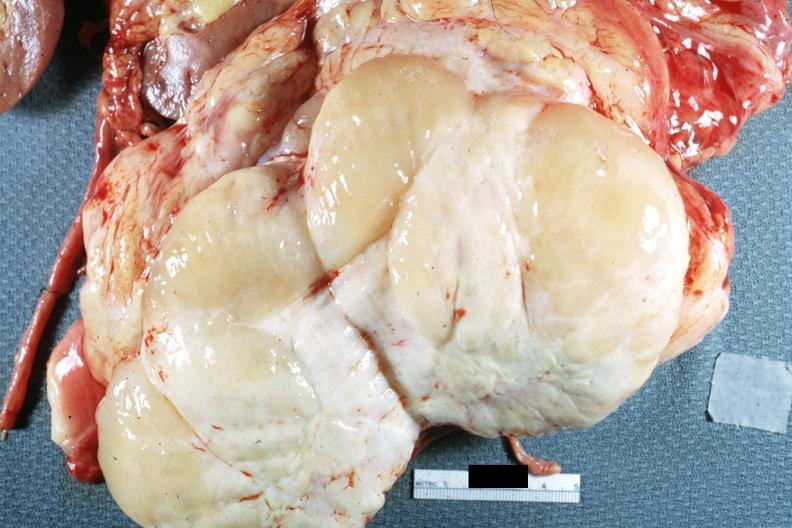does this image show nodular tumor cut surface natural color yellow and white typical gross sarcoma?
Answer the question using a single word or phrase. Yes 